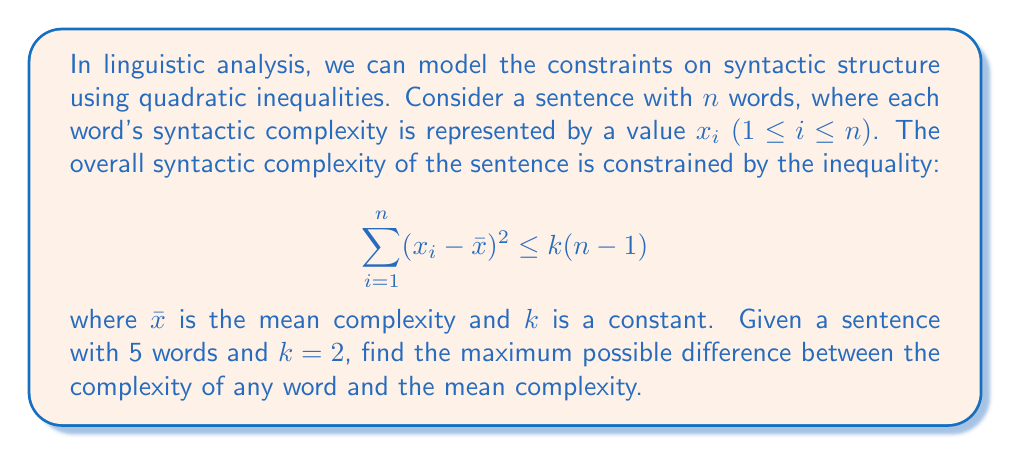Show me your answer to this math problem. Let's approach this step-by-step:

1) The inequality given is:
   $$\sum_{i=1}^n (x_i - \bar{x})^2 \leq k(n-1)$$

2) We're given that $n = 5$ and $k = 2$. Substituting these values:
   $$\sum_{i=1}^5 (x_i - \bar{x})^2 \leq 2(5-1) = 8$$

3) The left side of the inequality represents the sum of squared deviations from the mean. The maximum possible difference between any $x_i$ and $\bar{x}$ will occur when all of this "allowance" is concentrated in a single term.

4) Let's call the maximum difference $d$. Then:
   $$d^2 \leq 8$$

5) Solving for $d$:
   $$d \leq \sqrt{8} = 2\sqrt{2}$$

Therefore, the maximum possible difference between the complexity of any word and the mean complexity is $2\sqrt{2}$.
Answer: $2\sqrt{2}$ 